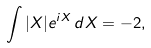Convert formula to latex. <formula><loc_0><loc_0><loc_500><loc_500>\int | X | e ^ { i X } \, d X = - 2 ,</formula> 